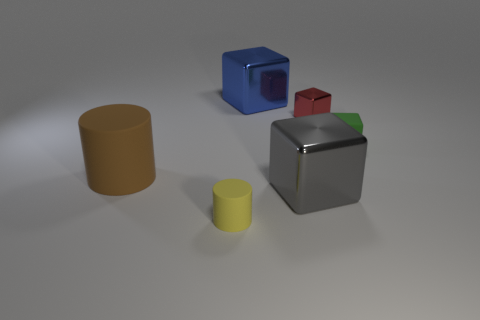Subtract 1 blocks. How many blocks are left? 3 Add 2 blue rubber cubes. How many objects exist? 8 Subtract all blocks. How many objects are left? 2 Add 5 rubber blocks. How many rubber blocks are left? 6 Add 3 purple shiny balls. How many purple shiny balls exist? 3 Subtract 1 brown cylinders. How many objects are left? 5 Subtract all blue rubber blocks. Subtract all big gray objects. How many objects are left? 5 